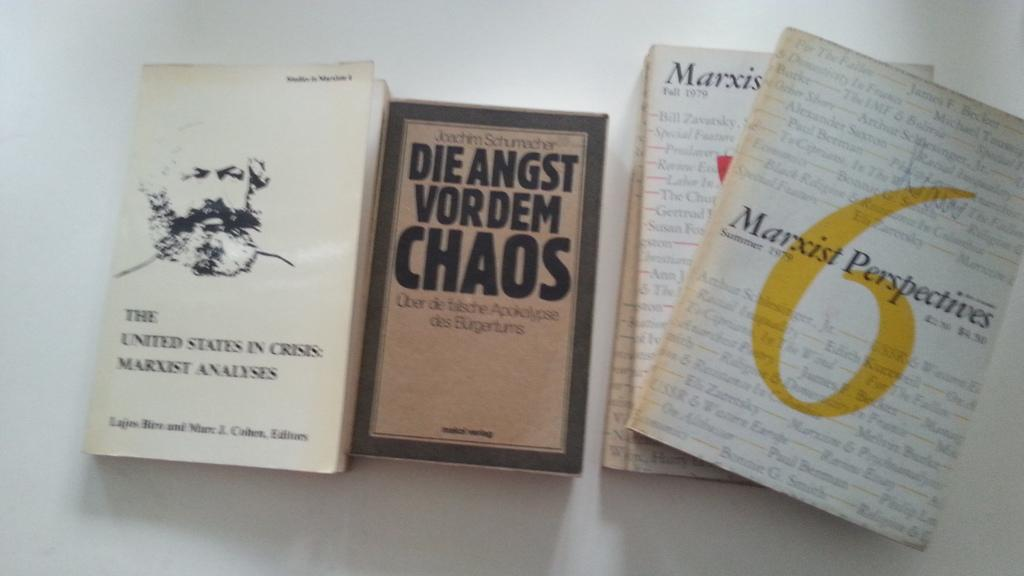Provide a one-sentence caption for the provided image. A copy of Die Angst Vordem Chaos sits with some other books. 